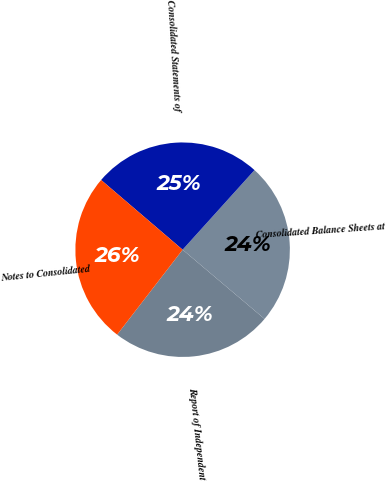Convert chart. <chart><loc_0><loc_0><loc_500><loc_500><pie_chart><fcel>Report of Independent<fcel>Consolidated Balance Sheets at<fcel>Consolidated Statements of<fcel>Notes to Consolidated<nl><fcel>24.29%<fcel>24.48%<fcel>25.43%<fcel>25.81%<nl></chart> 